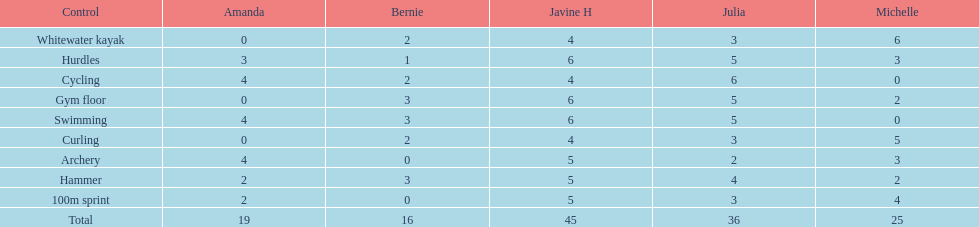Who had her best score in cycling? Julia. 